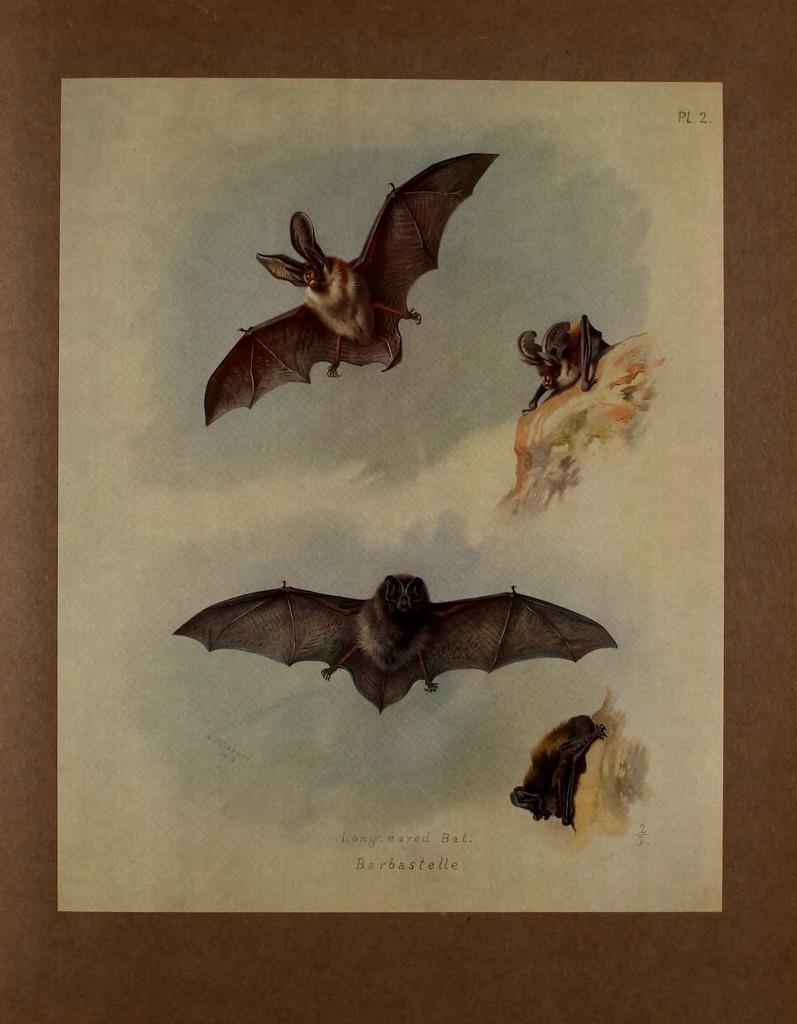Could you give a brief overview of what you see in this image? In this image we can see a paper on the wooden platform. On this paper we can see pictures of birds. 